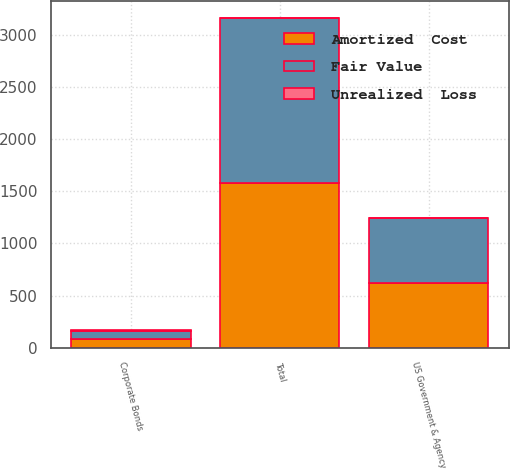Convert chart. <chart><loc_0><loc_0><loc_500><loc_500><stacked_bar_chart><ecel><fcel>US Government & Agency<fcel>Corporate Bonds<fcel>Total<nl><fcel>Fair Value<fcel>624<fcel>83<fcel>1583<nl><fcel>Unrealized  Loss<fcel>7<fcel>1<fcel>8<nl><fcel>Amortized  Cost<fcel>617<fcel>82<fcel>1575<nl></chart> 